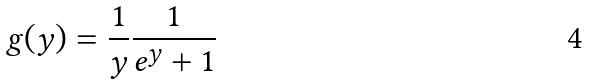<formula> <loc_0><loc_0><loc_500><loc_500>g ( y ) = \frac { 1 } { y } \frac { 1 } { e ^ { y } + 1 }</formula> 